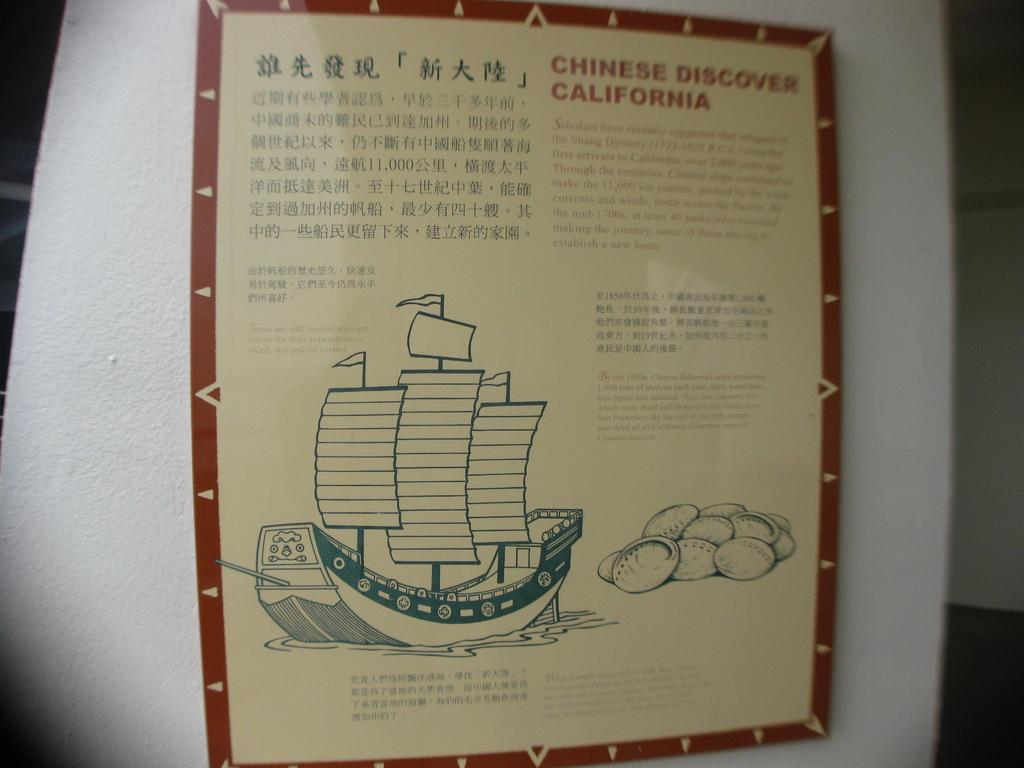<image>
Share a concise interpretation of the image provided. A drawing of a boat and asian text titled Chinese Discover California. 